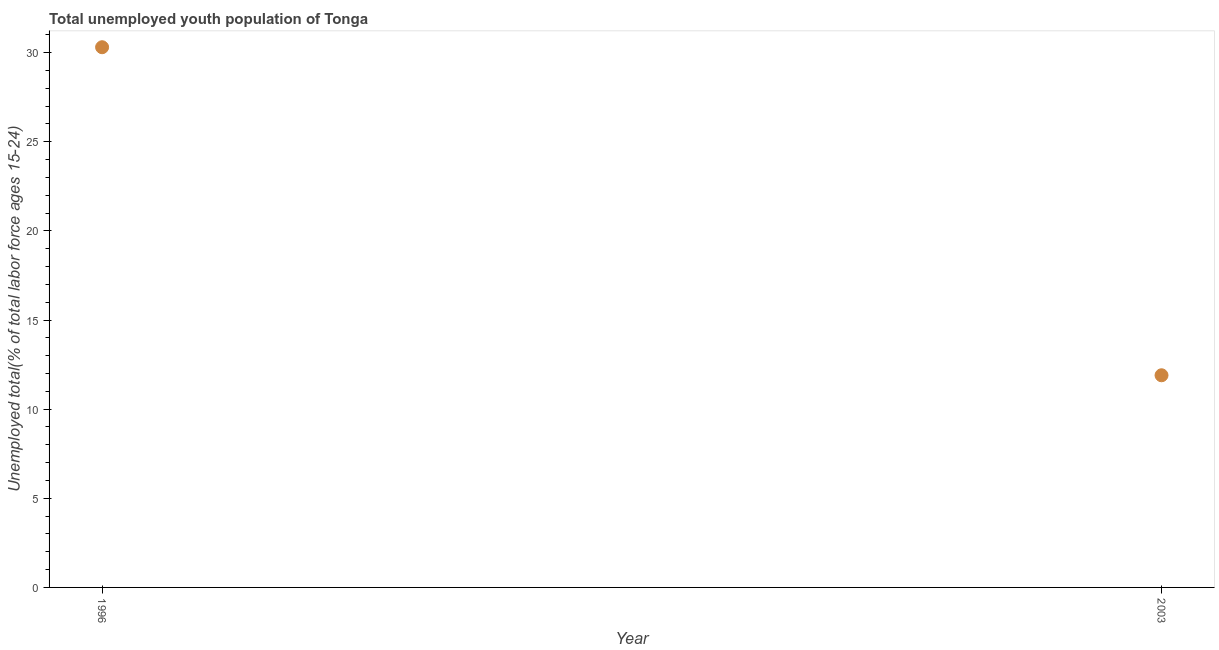What is the unemployed youth in 1996?
Offer a terse response. 30.3. Across all years, what is the maximum unemployed youth?
Give a very brief answer. 30.3. Across all years, what is the minimum unemployed youth?
Offer a terse response. 11.9. In which year was the unemployed youth maximum?
Provide a succinct answer. 1996. In which year was the unemployed youth minimum?
Your response must be concise. 2003. What is the sum of the unemployed youth?
Give a very brief answer. 42.2. What is the difference between the unemployed youth in 1996 and 2003?
Keep it short and to the point. 18.4. What is the average unemployed youth per year?
Keep it short and to the point. 21.1. What is the median unemployed youth?
Offer a terse response. 21.1. Do a majority of the years between 1996 and 2003 (inclusive) have unemployed youth greater than 30 %?
Your response must be concise. No. What is the ratio of the unemployed youth in 1996 to that in 2003?
Keep it short and to the point. 2.55. How many dotlines are there?
Offer a very short reply. 1. How many years are there in the graph?
Provide a succinct answer. 2. Are the values on the major ticks of Y-axis written in scientific E-notation?
Give a very brief answer. No. Does the graph contain grids?
Ensure brevity in your answer.  No. What is the title of the graph?
Offer a terse response. Total unemployed youth population of Tonga. What is the label or title of the X-axis?
Your answer should be very brief. Year. What is the label or title of the Y-axis?
Your response must be concise. Unemployed total(% of total labor force ages 15-24). What is the Unemployed total(% of total labor force ages 15-24) in 1996?
Offer a terse response. 30.3. What is the Unemployed total(% of total labor force ages 15-24) in 2003?
Make the answer very short. 11.9. What is the ratio of the Unemployed total(% of total labor force ages 15-24) in 1996 to that in 2003?
Make the answer very short. 2.55. 